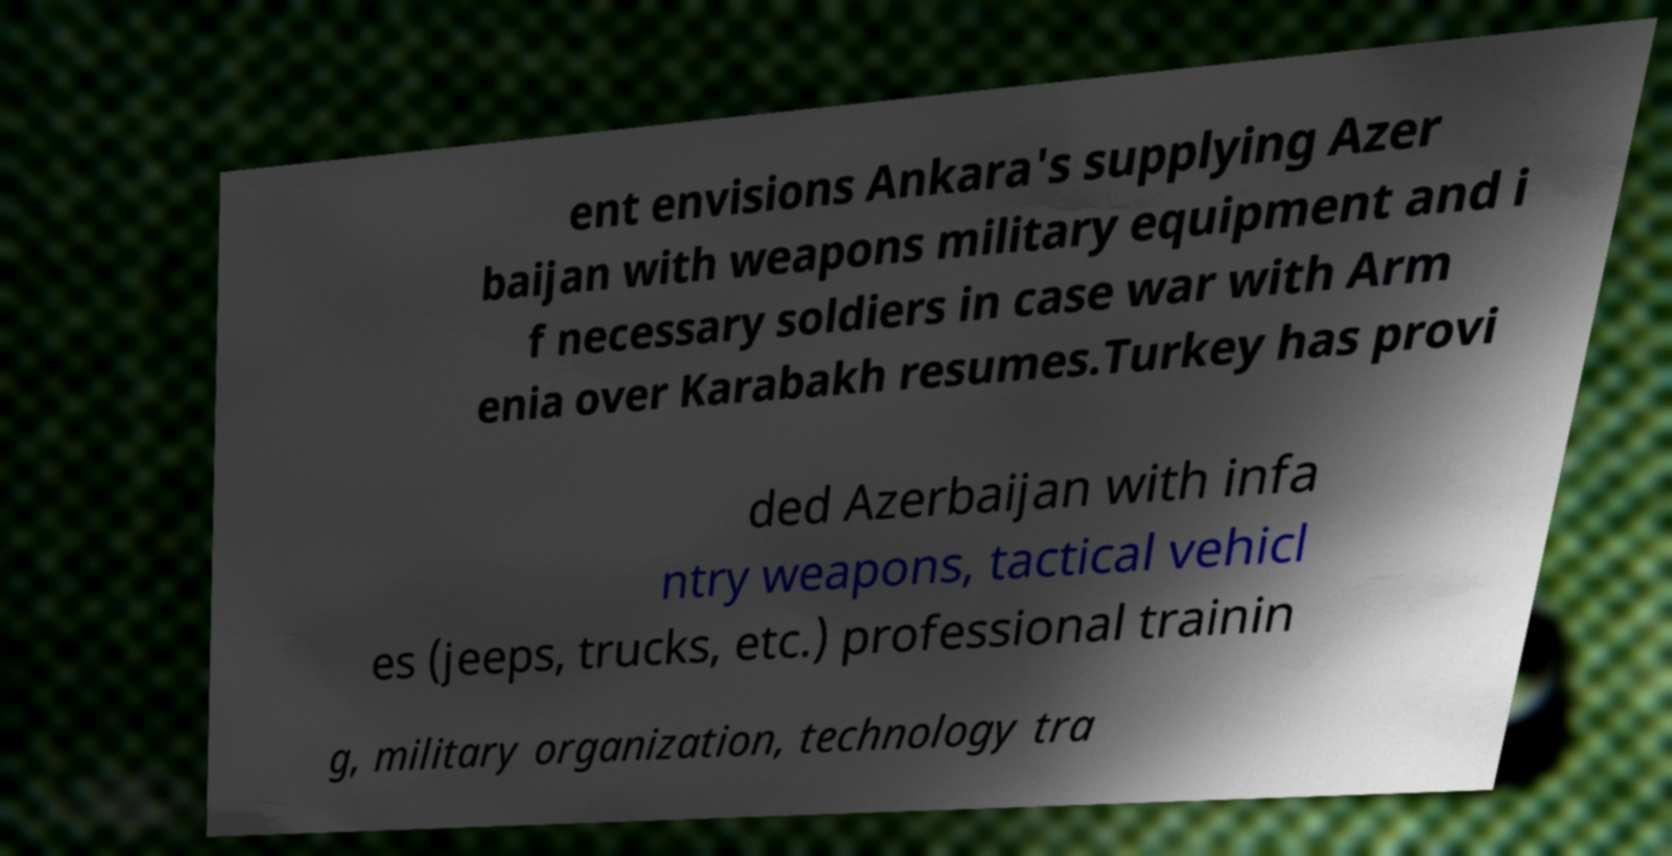What messages or text are displayed in this image? I need them in a readable, typed format. ent envisions Ankara's supplying Azer baijan with weapons military equipment and i f necessary soldiers in case war with Arm enia over Karabakh resumes.Turkey has provi ded Azerbaijan with infa ntry weapons, tactical vehicl es (jeeps, trucks, etc.) professional trainin g, military organization, technology tra 